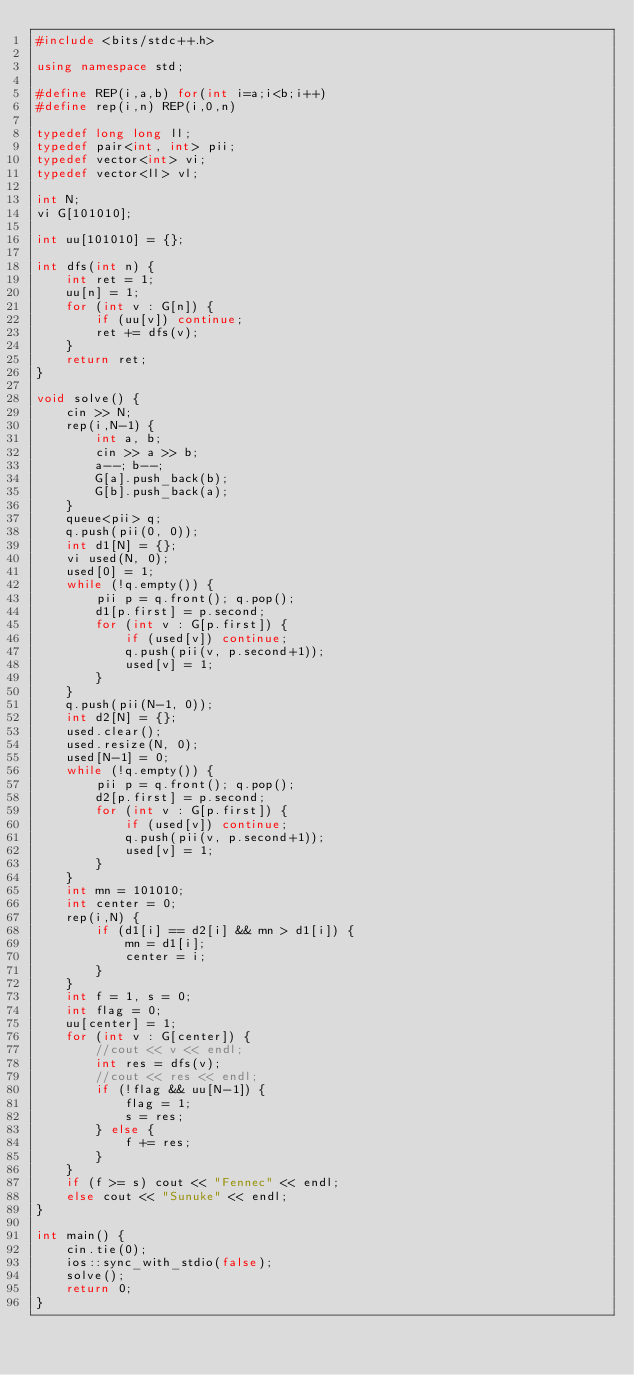<code> <loc_0><loc_0><loc_500><loc_500><_C++_>#include <bits/stdc++.h>

using namespace std;

#define REP(i,a,b) for(int i=a;i<b;i++)
#define rep(i,n) REP(i,0,n)

typedef long long ll;
typedef pair<int, int> pii;
typedef vector<int> vi;
typedef vector<ll> vl;

int N;
vi G[101010];

int uu[101010] = {};

int dfs(int n) {
    int ret = 1;
    uu[n] = 1;
    for (int v : G[n]) {
        if (uu[v]) continue;
        ret += dfs(v);
    }
    return ret;
}

void solve() {
    cin >> N;
    rep(i,N-1) {
        int a, b;
        cin >> a >> b;
        a--; b--;
        G[a].push_back(b);
        G[b].push_back(a);
    }
    queue<pii> q;
    q.push(pii(0, 0));
    int d1[N] = {};
    vi used(N, 0);
    used[0] = 1;
    while (!q.empty()) {
        pii p = q.front(); q.pop();
        d1[p.first] = p.second;
        for (int v : G[p.first]) {
            if (used[v]) continue;
            q.push(pii(v, p.second+1));
            used[v] = 1;
        }
    }
    q.push(pii(N-1, 0));
    int d2[N] = {};
    used.clear();
    used.resize(N, 0);
    used[N-1] = 0;
    while (!q.empty()) {
        pii p = q.front(); q.pop();
        d2[p.first] = p.second;
        for (int v : G[p.first]) {
            if (used[v]) continue;
            q.push(pii(v, p.second+1));
            used[v] = 1;
        }
    }
    int mn = 101010;
    int center = 0;
    rep(i,N) {
        if (d1[i] == d2[i] && mn > d1[i]) {
            mn = d1[i];
            center = i;
        }
    }
    int f = 1, s = 0;
    int flag = 0;
    uu[center] = 1;
    for (int v : G[center]) {
        //cout << v << endl;
        int res = dfs(v);
        //cout << res << endl;
        if (!flag && uu[N-1]) {
            flag = 1;
            s = res;
        } else {
            f += res;
        }
    }
    if (f >= s) cout << "Fennec" << endl;
    else cout << "Sunuke" << endl;
}

int main() {
    cin.tie(0);
   	ios::sync_with_stdio(false);
    solve();
    return 0;
}
</code> 